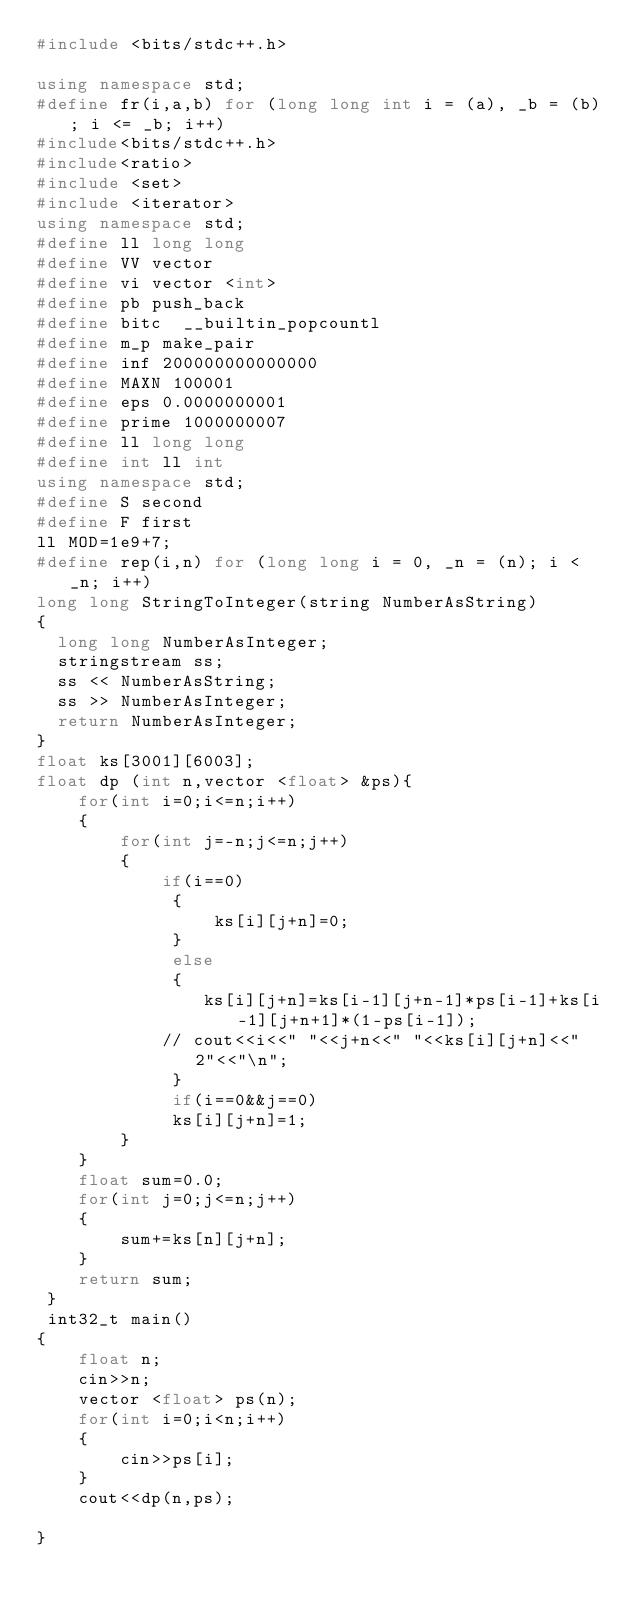Convert code to text. <code><loc_0><loc_0><loc_500><loc_500><_C++_>#include <bits/stdc++.h>
 
using namespace std;
#define fr(i,a,b) for (long long int i = (a), _b = (b); i <= _b; i++)
#include<bits/stdc++.h>
#include<ratio>
#include <set> 
#include <iterator>
using namespace std;
#define ll long long
#define VV vector
#define vi vector <int>
#define pb push_back
#define bitc  __builtin_popcountl
#define m_p make_pair
#define inf 200000000000000
#define MAXN 100001
#define eps 0.0000000001
#define prime 1000000007
#define ll long long
#define int ll int
using namespace std;
#define S second
#define F first
ll MOD=1e9+7;
#define rep(i,n) for (long long i = 0, _n = (n); i < _n; i++)
long long StringToInteger(string NumberAsString)
{
  long long NumberAsInteger;
  stringstream ss;
  ss << NumberAsString;
  ss >> NumberAsInteger;
  return NumberAsInteger;
}
float ks[3001][6003];
float dp (int n,vector <float> &ps){
    for(int i=0;i<=n;i++)
    {
        for(int j=-n;j<=n;j++)
        {
            if(i==0)
             {
                 ks[i][j+n]=0;
             }
             else
             {
                ks[i][j+n]=ks[i-1][j+n-1]*ps[i-1]+ks[i-1][j+n+1]*(1-ps[i-1]);
            // cout<<i<<" "<<j+n<<" "<<ks[i][j+n]<<" 2"<<"\n";
             }
             if(i==0&&j==0)
             ks[i][j+n]=1;
        }
    }
    float sum=0.0;
    for(int j=0;j<=n;j++)
    {
        sum+=ks[n][j+n];
    }
    return sum;
 }
 int32_t main()
{   
    float n;
    cin>>n;
    vector <float> ps(n);     
    for(int i=0;i<n;i++)
    {
        cin>>ps[i];  
    }
    cout<<dp(n,ps);

}</code> 